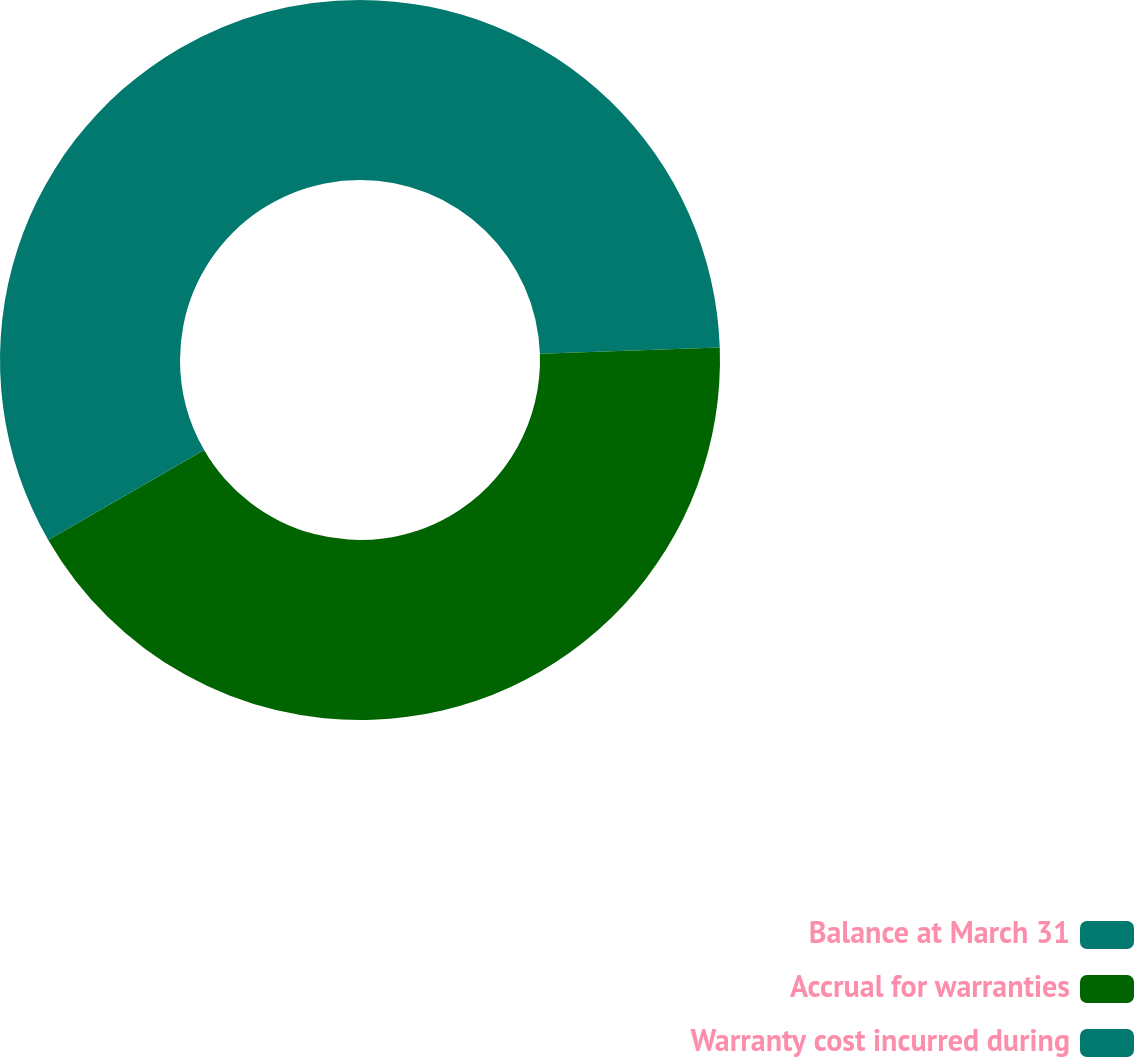<chart> <loc_0><loc_0><loc_500><loc_500><pie_chart><fcel>Balance at March 31<fcel>Accrual for warranties<fcel>Warranty cost incurred during<nl><fcel>24.45%<fcel>42.21%<fcel>33.33%<nl></chart> 